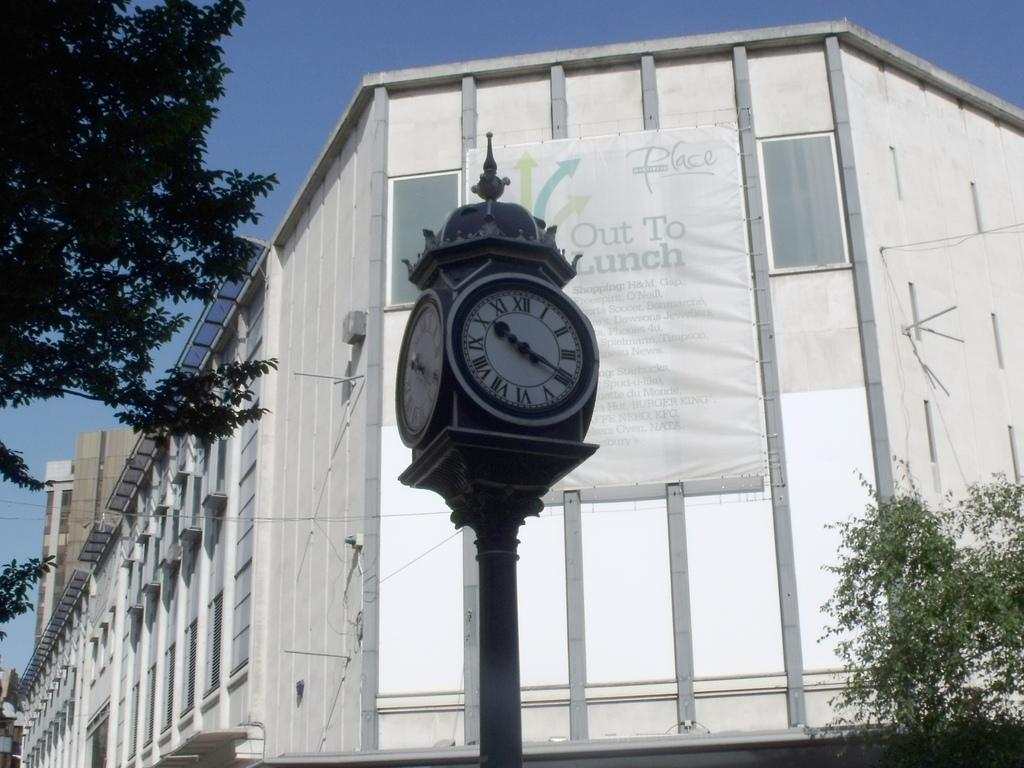<image>
Give a short and clear explanation of the subsequent image. A clock is outside a building that has an out to lunch sign on it. 